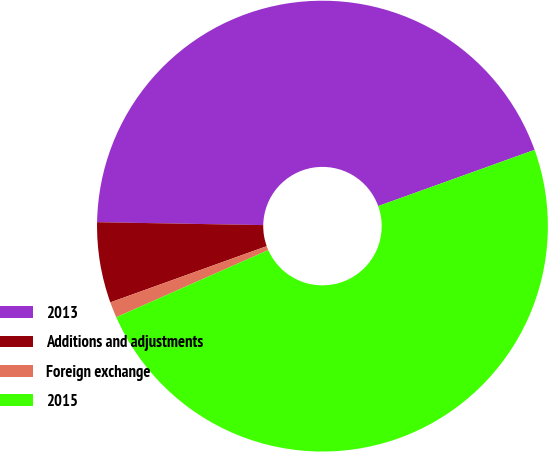Convert chart to OTSL. <chart><loc_0><loc_0><loc_500><loc_500><pie_chart><fcel>2013<fcel>Additions and adjustments<fcel>Foreign exchange<fcel>2015<nl><fcel>44.23%<fcel>5.77%<fcel>1.13%<fcel>48.87%<nl></chart> 